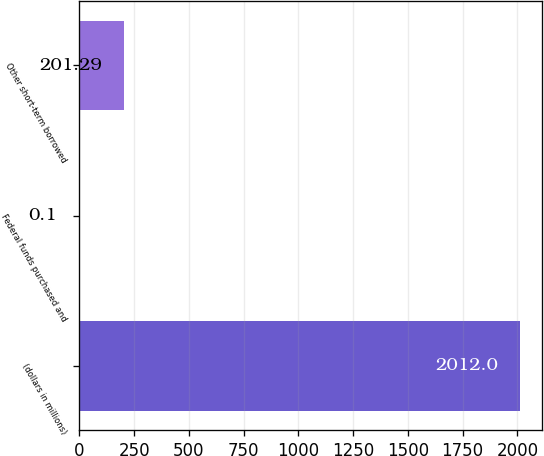Convert chart to OTSL. <chart><loc_0><loc_0><loc_500><loc_500><bar_chart><fcel>(dollars in millions)<fcel>Federal funds purchased and<fcel>Other short-term borrowed<nl><fcel>2012<fcel>0.1<fcel>201.29<nl></chart> 